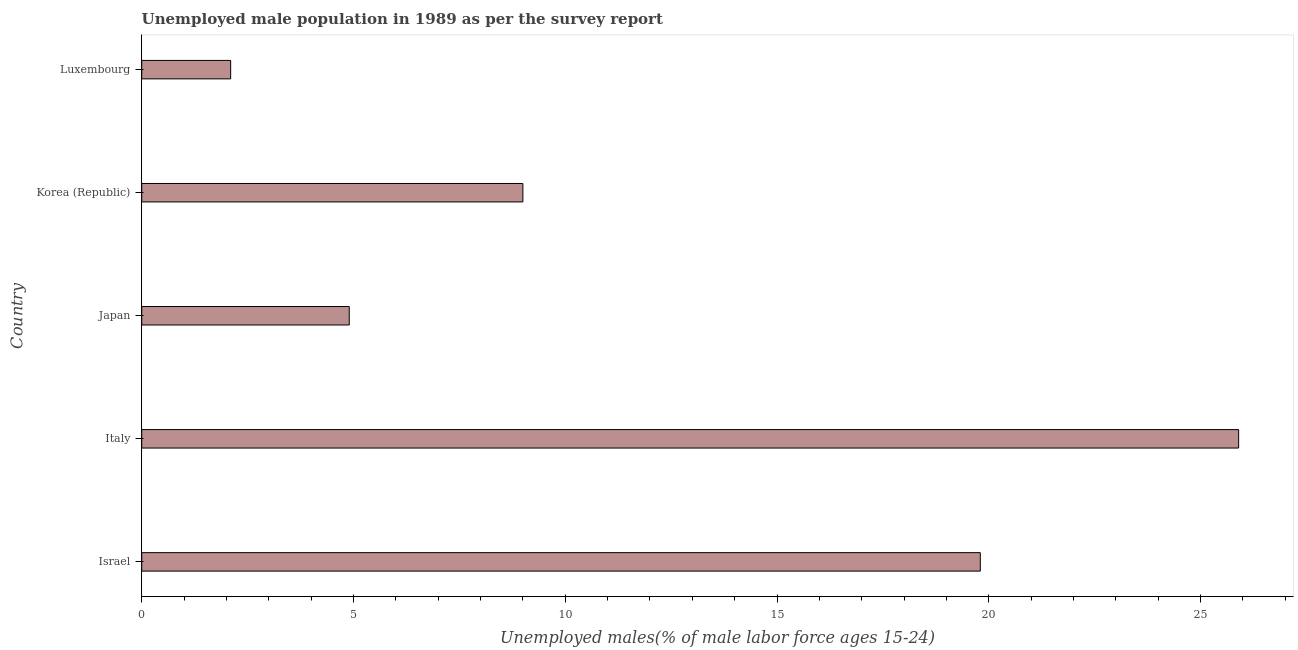Does the graph contain grids?
Provide a succinct answer. No. What is the title of the graph?
Your answer should be compact. Unemployed male population in 1989 as per the survey report. What is the label or title of the X-axis?
Provide a succinct answer. Unemployed males(% of male labor force ages 15-24). What is the label or title of the Y-axis?
Your response must be concise. Country. What is the unemployed male youth in Italy?
Provide a short and direct response. 25.9. Across all countries, what is the maximum unemployed male youth?
Make the answer very short. 25.9. Across all countries, what is the minimum unemployed male youth?
Make the answer very short. 2.1. In which country was the unemployed male youth minimum?
Your response must be concise. Luxembourg. What is the sum of the unemployed male youth?
Offer a terse response. 61.7. What is the average unemployed male youth per country?
Make the answer very short. 12.34. What is the median unemployed male youth?
Ensure brevity in your answer.  9. What is the ratio of the unemployed male youth in Israel to that in Luxembourg?
Make the answer very short. 9.43. Is the unemployed male youth in Japan less than that in Luxembourg?
Give a very brief answer. No. Is the difference between the unemployed male youth in Israel and Luxembourg greater than the difference between any two countries?
Your response must be concise. No. What is the difference between the highest and the lowest unemployed male youth?
Give a very brief answer. 23.8. In how many countries, is the unemployed male youth greater than the average unemployed male youth taken over all countries?
Provide a short and direct response. 2. How many countries are there in the graph?
Ensure brevity in your answer.  5. What is the difference between two consecutive major ticks on the X-axis?
Offer a very short reply. 5. What is the Unemployed males(% of male labor force ages 15-24) in Israel?
Offer a terse response. 19.8. What is the Unemployed males(% of male labor force ages 15-24) in Italy?
Your answer should be compact. 25.9. What is the Unemployed males(% of male labor force ages 15-24) in Japan?
Your answer should be compact. 4.9. What is the Unemployed males(% of male labor force ages 15-24) of Luxembourg?
Your answer should be compact. 2.1. What is the difference between the Unemployed males(% of male labor force ages 15-24) in Israel and Korea (Republic)?
Your answer should be compact. 10.8. What is the difference between the Unemployed males(% of male labor force ages 15-24) in Israel and Luxembourg?
Keep it short and to the point. 17.7. What is the difference between the Unemployed males(% of male labor force ages 15-24) in Italy and Luxembourg?
Ensure brevity in your answer.  23.8. What is the difference between the Unemployed males(% of male labor force ages 15-24) in Japan and Luxembourg?
Your answer should be compact. 2.8. What is the ratio of the Unemployed males(% of male labor force ages 15-24) in Israel to that in Italy?
Keep it short and to the point. 0.76. What is the ratio of the Unemployed males(% of male labor force ages 15-24) in Israel to that in Japan?
Provide a succinct answer. 4.04. What is the ratio of the Unemployed males(% of male labor force ages 15-24) in Israel to that in Luxembourg?
Your answer should be compact. 9.43. What is the ratio of the Unemployed males(% of male labor force ages 15-24) in Italy to that in Japan?
Provide a short and direct response. 5.29. What is the ratio of the Unemployed males(% of male labor force ages 15-24) in Italy to that in Korea (Republic)?
Give a very brief answer. 2.88. What is the ratio of the Unemployed males(% of male labor force ages 15-24) in Italy to that in Luxembourg?
Provide a succinct answer. 12.33. What is the ratio of the Unemployed males(% of male labor force ages 15-24) in Japan to that in Korea (Republic)?
Ensure brevity in your answer.  0.54. What is the ratio of the Unemployed males(% of male labor force ages 15-24) in Japan to that in Luxembourg?
Your answer should be very brief. 2.33. What is the ratio of the Unemployed males(% of male labor force ages 15-24) in Korea (Republic) to that in Luxembourg?
Ensure brevity in your answer.  4.29. 